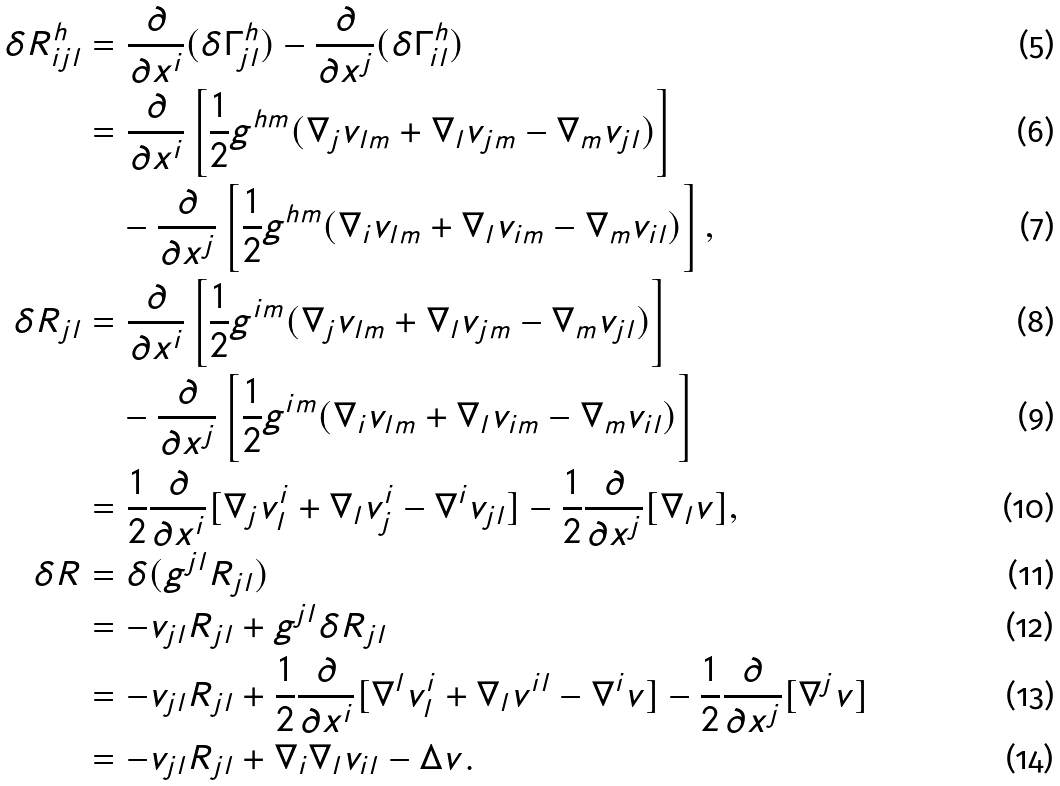<formula> <loc_0><loc_0><loc_500><loc_500>\delta R ^ { h } _ { i j l } & = \frac { \partial } { \partial x ^ { i } } ( \delta \Gamma ^ { h } _ { j l } ) - \frac { \partial } { \partial x ^ { j } } ( \delta \Gamma ^ { h } _ { i l } ) \\ & = \frac { \partial } { \partial x ^ { i } } \left [ \frac { 1 } { 2 } g ^ { h m } ( \nabla _ { j } v _ { l m } + \nabla _ { l } v _ { j m } - \nabla _ { m } v _ { j l } ) \right ] \\ & \quad - \frac { \partial } { \partial x ^ { j } } \left [ \frac { 1 } { 2 } g ^ { h m } ( \nabla _ { i } v _ { l m } + \nabla _ { l } v _ { i m } - \nabla _ { m } v _ { i l } ) \right ] , \\ \delta R _ { j l } & = \frac { \partial } { \partial x ^ { i } } \left [ \frac { 1 } { 2 } g ^ { i m } ( \nabla _ { j } v _ { l m } + \nabla _ { l } v _ { j m } - \nabla _ { m } v _ { j l } ) \right ] \\ & \quad - \frac { \partial } { \partial x ^ { j } } \left [ \frac { 1 } { 2 } g ^ { i m } ( \nabla _ { i } v _ { l m } + \nabla _ { l } v _ { i m } - \nabla _ { m } v _ { i l } ) \right ] \\ & = \frac { 1 } { 2 } \frac { \partial } { \partial x ^ { i } } [ \nabla _ { j } v ^ { i } _ { l } + \nabla _ { l } v ^ { i } _ { j } - \nabla ^ { i } v _ { j l } ] - \frac { 1 } { 2 } \frac { \partial } { \partial x ^ { j } } [ \nabla _ { l } v ] , \\ \delta R & = \delta ( g ^ { j l } R _ { j l } ) \\ & = - v _ { j l } R _ { j l } + g ^ { j l } \delta R _ { j l } \\ & = - v _ { j l } R _ { j l } + \frac { 1 } { 2 } \frac { \partial } { \partial x ^ { i } } [ \nabla ^ { l } v ^ { i } _ { l } + \nabla _ { l } v ^ { i l } - \nabla ^ { i } v ] - \frac { 1 } { 2 } \frac { \partial } { \partial x ^ { j } } [ \nabla ^ { j } v ] \\ & = - v _ { j l } R _ { j l } + \nabla _ { i } \nabla _ { l } v _ { i l } - \Delta v .</formula> 